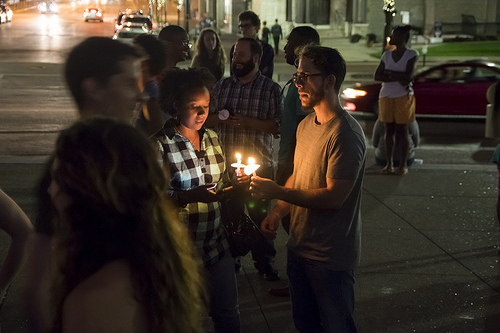<image>
Is there a car behind the man? Yes. From this viewpoint, the car is positioned behind the man, with the man partially or fully occluding the car. Is the boy to the left of the girl? No. The boy is not to the left of the girl. From this viewpoint, they have a different horizontal relationship. 